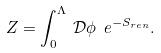Convert formula to latex. <formula><loc_0><loc_0><loc_500><loc_500>Z = \int _ { 0 } ^ { \Lambda } \, \mathcal { D } \phi \ e ^ { - S _ { r e n } } .</formula> 